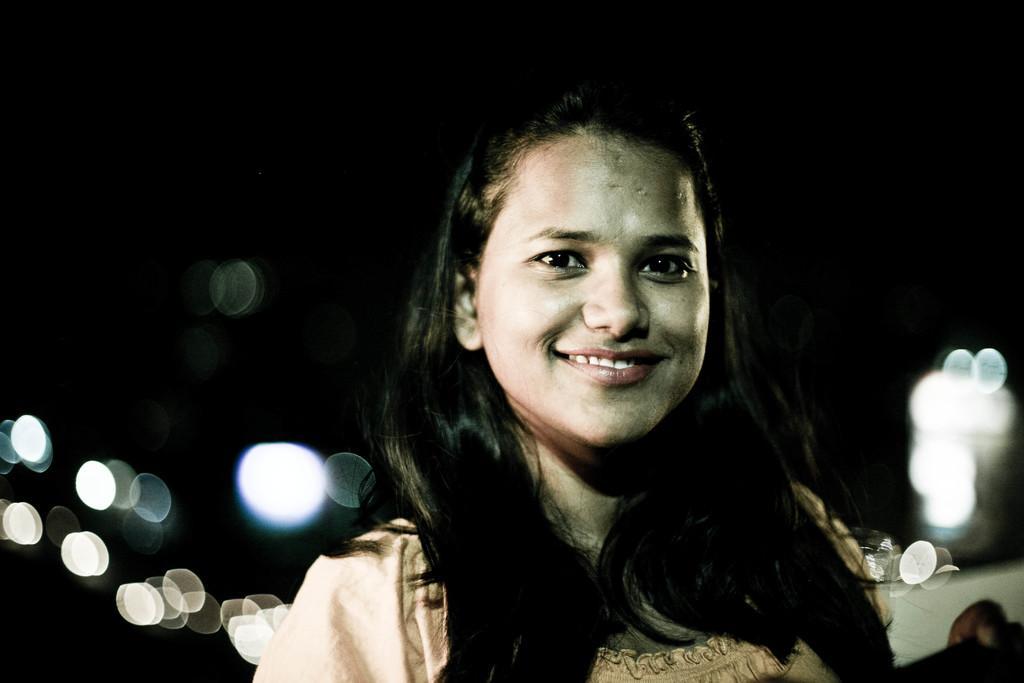Describe this image in one or two sentences. In this image there is one person is smiling is on the right side of this image. 